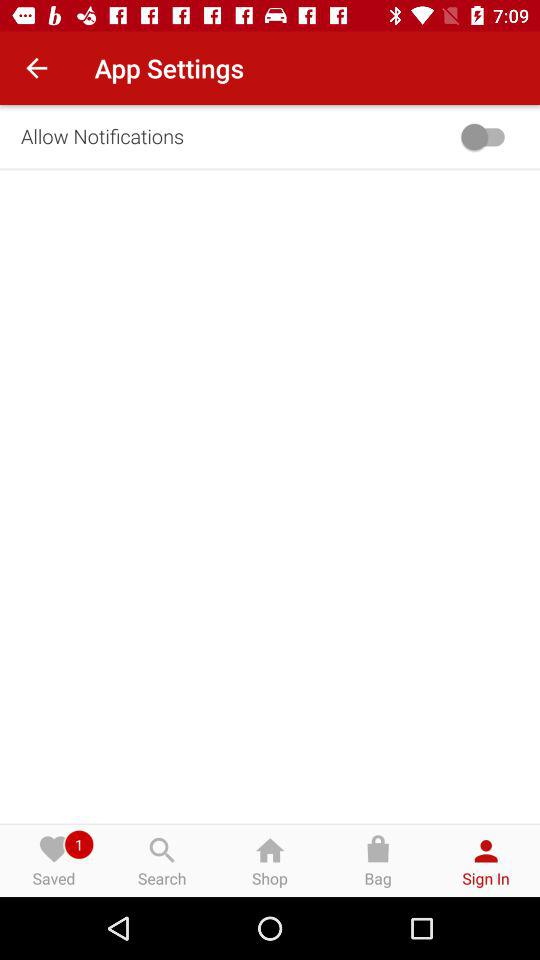Which tab is selected? The selected tab is "Sign In". 